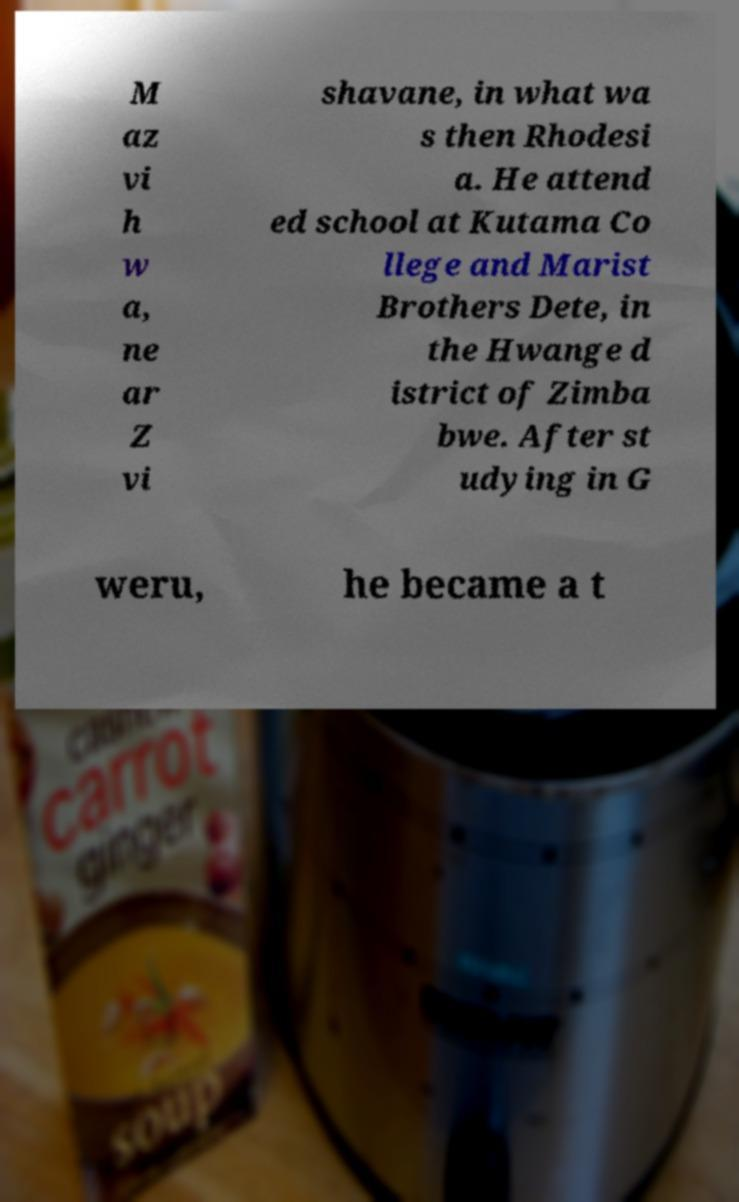Could you extract and type out the text from this image? M az vi h w a, ne ar Z vi shavane, in what wa s then Rhodesi a. He attend ed school at Kutama Co llege and Marist Brothers Dete, in the Hwange d istrict of Zimba bwe. After st udying in G weru, he became a t 